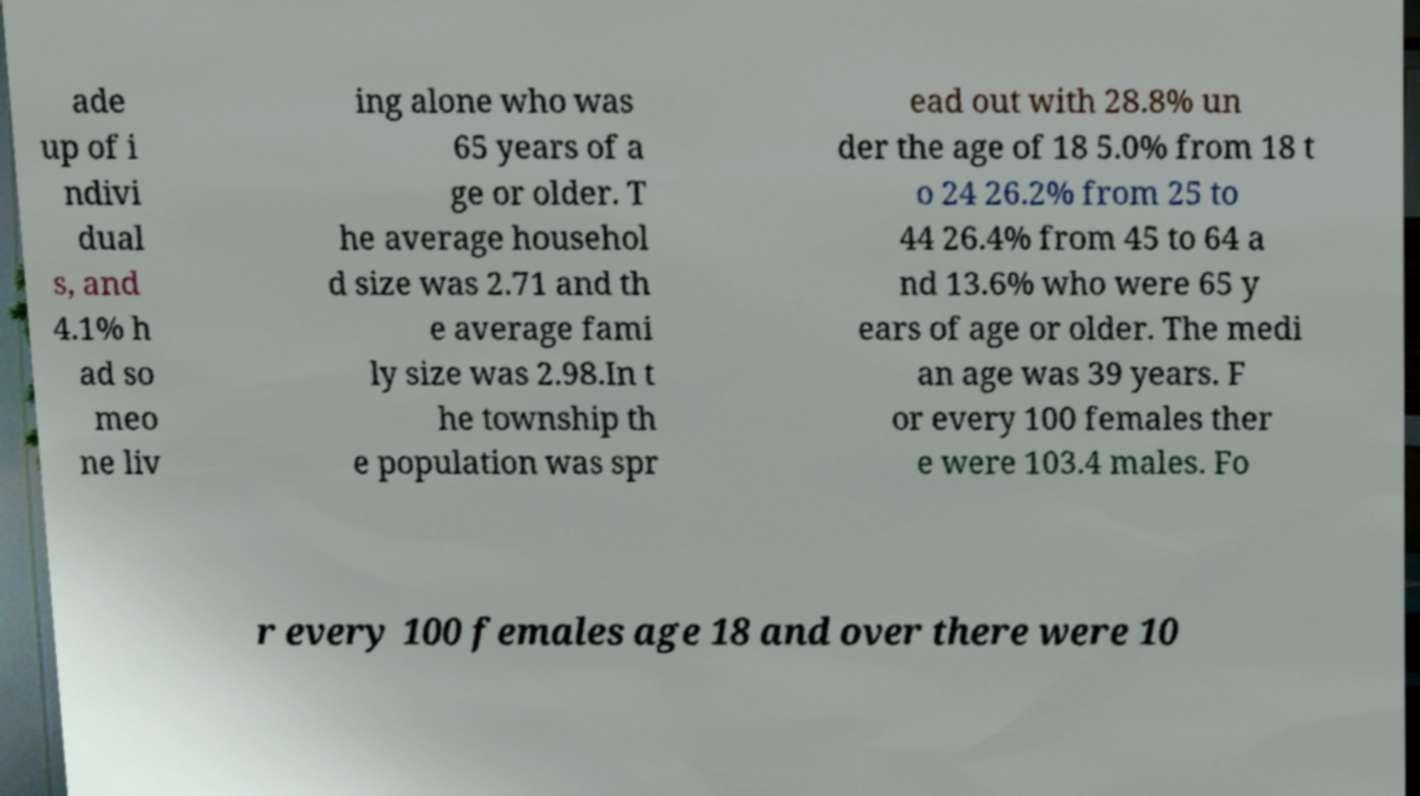For documentation purposes, I need the text within this image transcribed. Could you provide that? ade up of i ndivi dual s, and 4.1% h ad so meo ne liv ing alone who was 65 years of a ge or older. T he average househol d size was 2.71 and th e average fami ly size was 2.98.In t he township th e population was spr ead out with 28.8% un der the age of 18 5.0% from 18 t o 24 26.2% from 25 to 44 26.4% from 45 to 64 a nd 13.6% who were 65 y ears of age or older. The medi an age was 39 years. F or every 100 females ther e were 103.4 males. Fo r every 100 females age 18 and over there were 10 